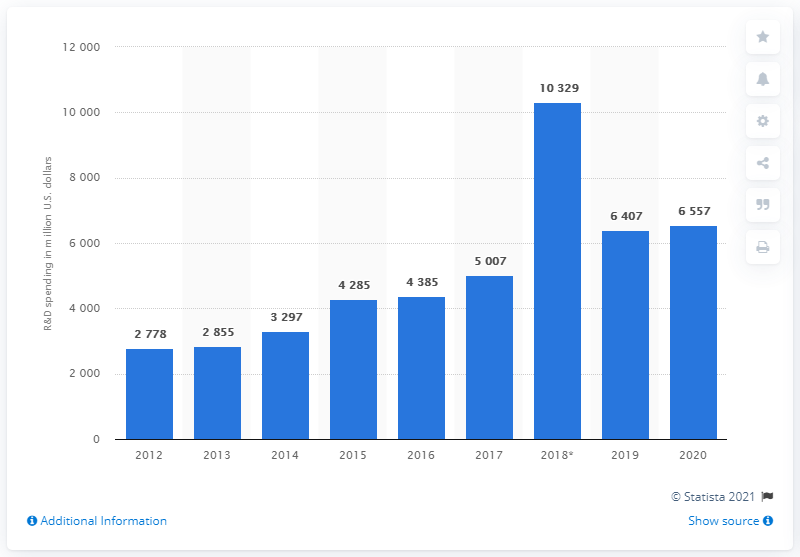Give some essential details in this illustration. AbbVie's expenditure on research and development in 2020 was approximately 6,557. 